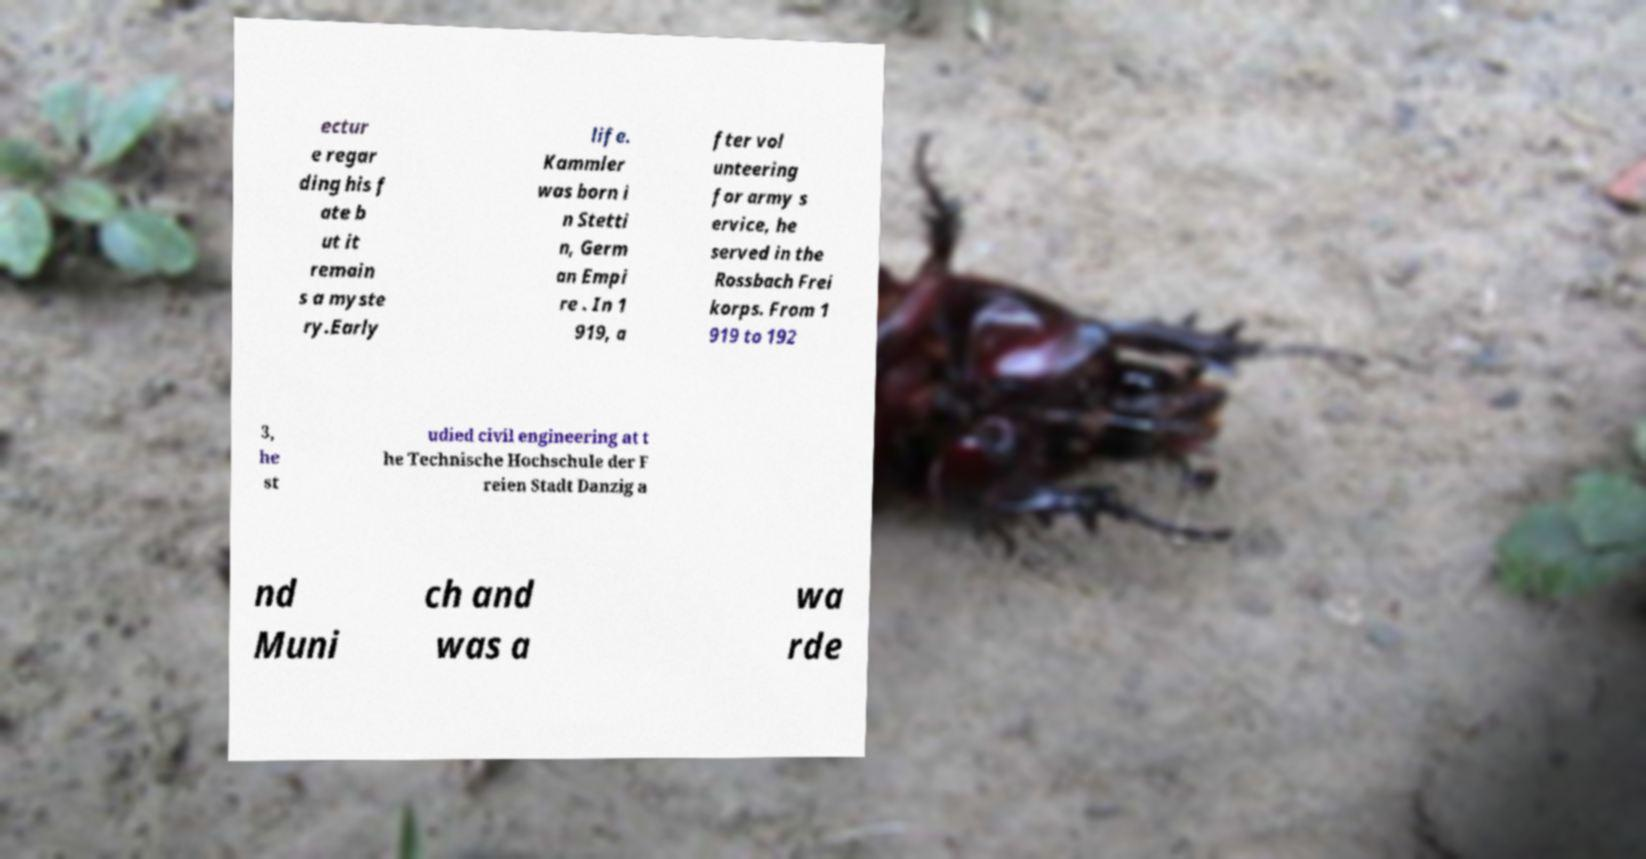Could you extract and type out the text from this image? ectur e regar ding his f ate b ut it remain s a myste ry.Early life. Kammler was born i n Stetti n, Germ an Empi re . In 1 919, a fter vol unteering for army s ervice, he served in the Rossbach Frei korps. From 1 919 to 192 3, he st udied civil engineering at t he Technische Hochschule der F reien Stadt Danzig a nd Muni ch and was a wa rde 